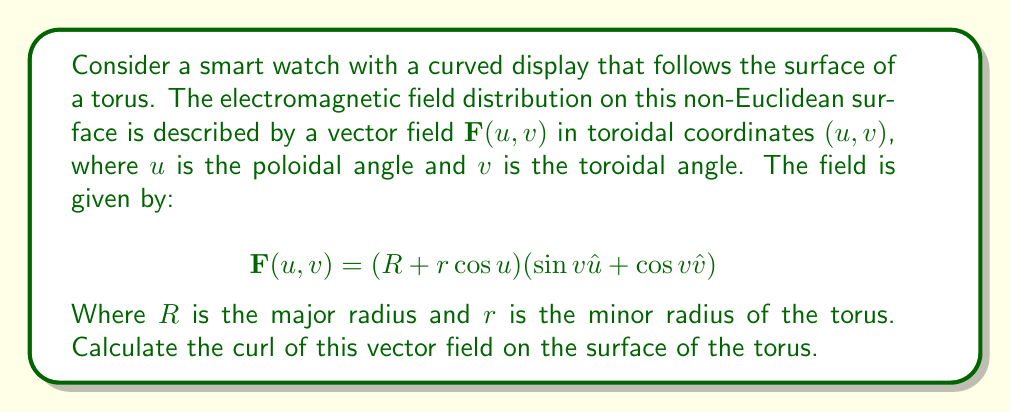Can you answer this question? To solve this problem, we need to follow these steps:

1) First, recall that the curl of a vector field $\mathbf{F}$ in curvilinear coordinates $(u,v)$ is given by:

   $$\text{curl}\mathbf{F} = \frac{1}{h_u h_v} \left(\frac{\partial}{\partial u}(h_v F_v) - \frac{\partial}{\partial v}(h_u F_u)\right)\hat{n}$$

   Where $h_u$ and $h_v$ are the scale factors, and $\hat{n}$ is the unit normal vector to the surface.

2) For a torus, the scale factors are:
   
   $h_u = r$
   $h_v = R + r\cos u$

3) From the given vector field, we can identify:

   $F_u = (R + r\cos u)\sin v$
   $F_v = (R + r\cos u)\cos v$

4) Now, let's calculate the partial derivatives:

   $$\frac{\partial}{\partial u}(h_v F_v) = \frac{\partial}{\partial u}((R + r\cos u)^2 \cos v) = -2r(R + r\cos u)\cos u \cos v$$

   $$\frac{\partial}{\partial v}(h_u F_u) = \frac{\partial}{\partial v}(r(R + r\cos u)\sin v) = r(R + r\cos u)\cos v$$

5) Substituting these into the curl formula:

   $$\text{curl}\mathbf{F} = \frac{1}{r(R + r\cos u)} (-2r(R + r\cos u)\cos u \cos v - r(R + r\cos u)\cos v)\hat{n}$$

6) Simplifying:

   $$\text{curl}\mathbf{F} = \frac{-1}{r}(2r\cos u \cos v + r\cos v)\hat{n} = (-2\cos u \cos v - \cos v)\hat{n}$$

7) This can be further factored to:

   $$\text{curl}\mathbf{F} = -(2\cos u + 1)\cos v\hat{n}$$
Answer: The curl of the vector field $\mathbf{F}(u,v)$ on the surface of the torus is:

$$\text{curl}\mathbf{F} = -(2\cos u + 1)\cos v\hat{n}$$

Where $\hat{n}$ is the unit normal vector to the surface of the torus. 